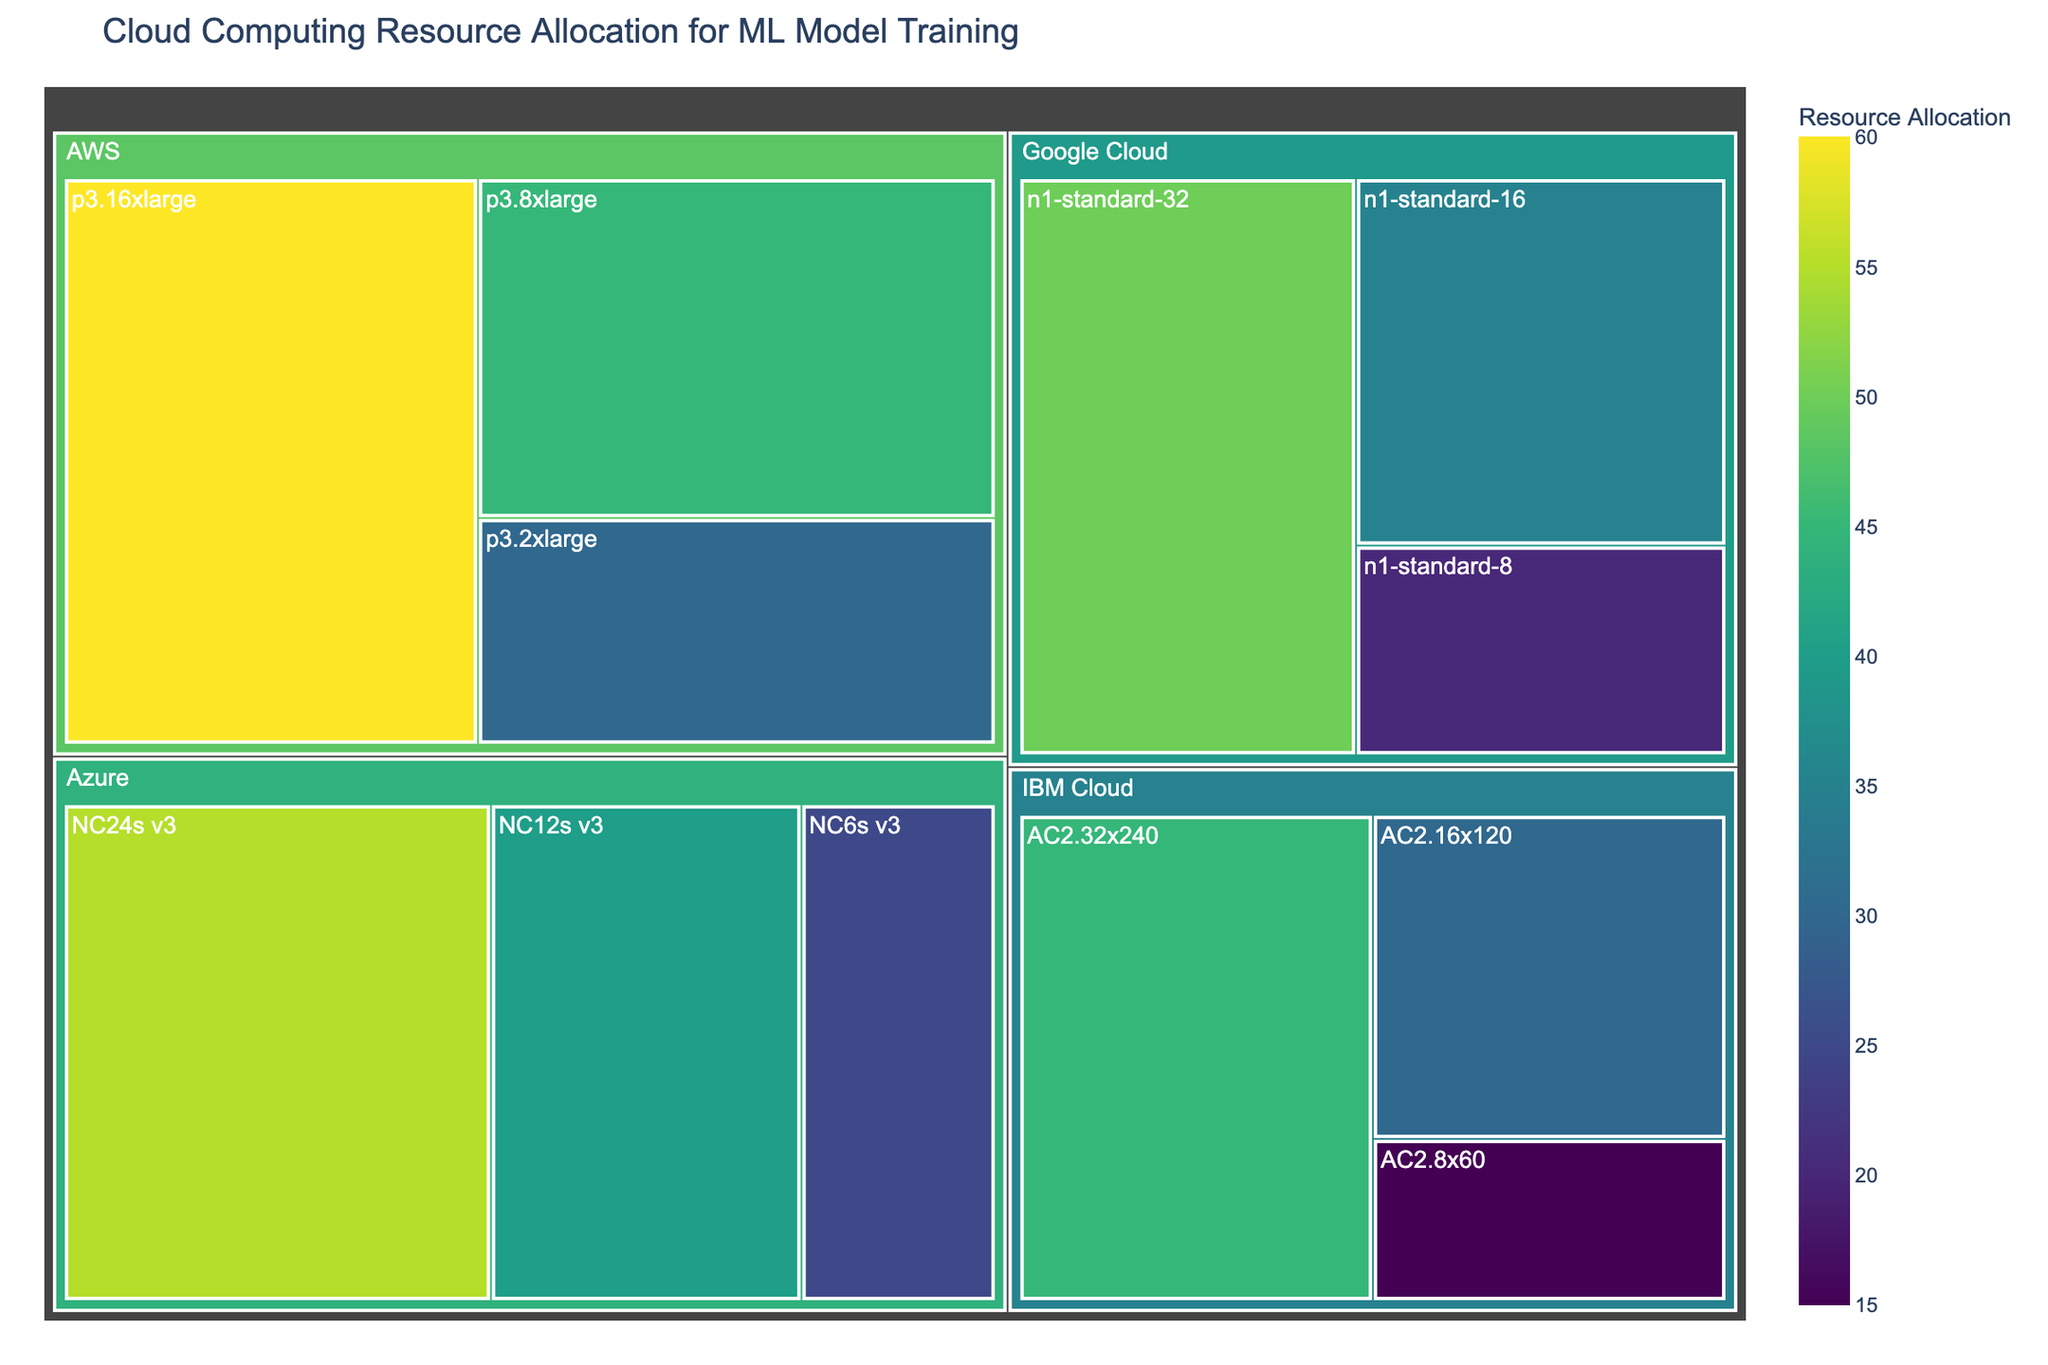What provider has the highest total resource allocation? To find which provider has the highest total resource allocation, we should sum the resource allocations for each instance type within each provider. AWS: 30 + 45 + 60 = 135, Google Cloud: 20 + 35 + 50 = 105, Azure: 25 + 40 + 55 = 120, IBM Cloud: 15 + 30 + 45 = 90. Therefore, AWS has the highest total resource allocation.
Answer: AWS How many different instance types are represented in the Treemap? There are instance types listed under each provider. Counting all unique instance types: p3.2xlarge, p3.8xlarge, p3.16xlarge, n1-standard-8, n1-standard-16, n1-standard-32, NC6s v3, NC12s v3, NC24s v3, AC2.8x60, AC2.16x120, AC2.32x240, yields 12 unique instance types.
Answer: 12 Which provider has the least average resource allocation per instance type? To calculate the average resource allocation per instance for each provider:
AWS: (30 + 45 + 60) / 3 = 45. 
Google Cloud: (20 + 35 + 50) / 3 ≈ 35. 
Azure: (25 + 40 + 55) / 3 ≈ 40. 
IBM Cloud: (15 + 30 + 45) / 3 = 30. 
IBM Cloud has the least average resource allocation per instance type.
Answer: IBM Cloud What is the color that represents the highest resource allocation value and which instance type does it correspond to? The highest resource allocation value is 60, and it is associated with the AWS p3.16xlarge instance type. The color representing higher values in the Viridis scale is a bright yellow-green.
Answer: Bright yellow-green, AWS p3.16xlarge Which instance type of Google Cloud has the highest resource allocation? By observing the Treemap, the Google Cloud instance type with the highest resource allocation is the n1-standard-32 with a value of 50.
Answer: n1-standard-32 What is the total resource allocation by Azure? To find Azure's total resource allocation, sum the resource allocations for its instance types: 25 (NC6s v3) + 40 (NC12s v3) + 55 (NC24s v3) = 120.
Answer: 120 How does the resource allocation for IBM Cloud’s AC2.32x240 compare to Azure’s NC24s v3? AC2.32x240 has a resource allocation of 45, while NC24s v3 has a resource allocation of 55. Therefore, Azure’s NC24s v3 has a higher resource allocation compared to IBM Cloud's AC2.32x240.
Answer: Azure’s NC24s v3 has higher resource allocation than IBM Cloud's AC2.32x240 Is there any instance type with resource allocation above 50 in the Treemap? By examining the Treemap, we can see that two instance types have a resource allocation above 50: AWS p3.16xlarge (60) and Azure NC24s v3 (55).
Answer: Yes 